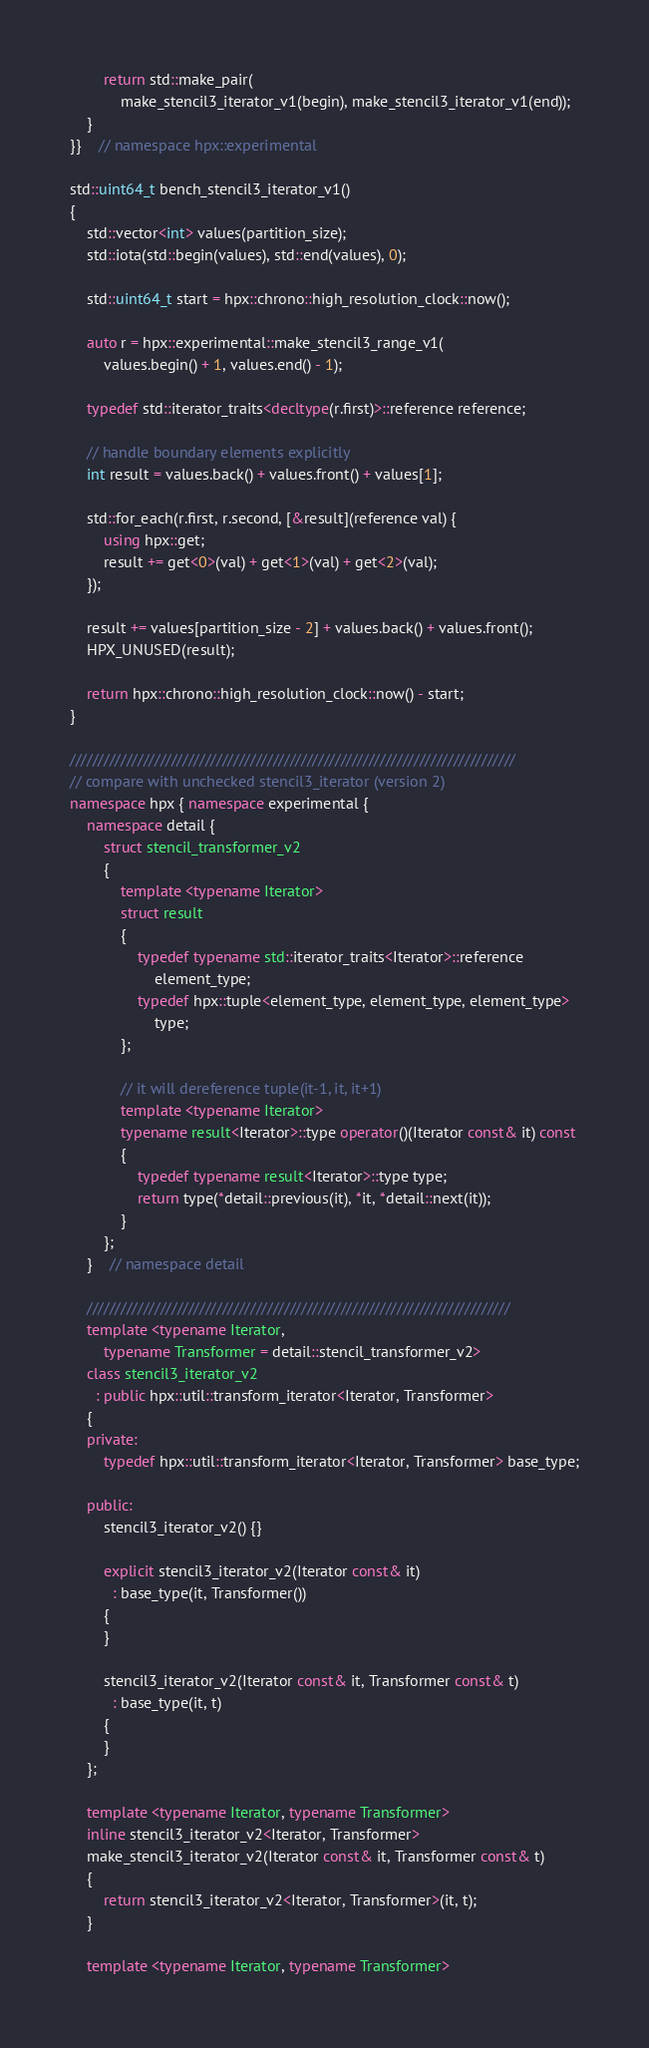Convert code to text. <code><loc_0><loc_0><loc_500><loc_500><_C++_>        return std::make_pair(
            make_stencil3_iterator_v1(begin), make_stencil3_iterator_v1(end));
    }
}}    // namespace hpx::experimental

std::uint64_t bench_stencil3_iterator_v1()
{
    std::vector<int> values(partition_size);
    std::iota(std::begin(values), std::end(values), 0);

    std::uint64_t start = hpx::chrono::high_resolution_clock::now();

    auto r = hpx::experimental::make_stencil3_range_v1(
        values.begin() + 1, values.end() - 1);

    typedef std::iterator_traits<decltype(r.first)>::reference reference;

    // handle boundary elements explicitly
    int result = values.back() + values.front() + values[1];

    std::for_each(r.first, r.second, [&result](reference val) {
        using hpx::get;
        result += get<0>(val) + get<1>(val) + get<2>(val);
    });

    result += values[partition_size - 2] + values.back() + values.front();
    HPX_UNUSED(result);

    return hpx::chrono::high_resolution_clock::now() - start;
}

///////////////////////////////////////////////////////////////////////////////
// compare with unchecked stencil3_iterator (version 2)
namespace hpx { namespace experimental {
    namespace detail {
        struct stencil_transformer_v2
        {
            template <typename Iterator>
            struct result
            {
                typedef typename std::iterator_traits<Iterator>::reference
                    element_type;
                typedef hpx::tuple<element_type, element_type, element_type>
                    type;
            };

            // it will dereference tuple(it-1, it, it+1)
            template <typename Iterator>
            typename result<Iterator>::type operator()(Iterator const& it) const
            {
                typedef typename result<Iterator>::type type;
                return type(*detail::previous(it), *it, *detail::next(it));
            }
        };
    }    // namespace detail

    ///////////////////////////////////////////////////////////////////////////
    template <typename Iterator,
        typename Transformer = detail::stencil_transformer_v2>
    class stencil3_iterator_v2
      : public hpx::util::transform_iterator<Iterator, Transformer>
    {
    private:
        typedef hpx::util::transform_iterator<Iterator, Transformer> base_type;

    public:
        stencil3_iterator_v2() {}

        explicit stencil3_iterator_v2(Iterator const& it)
          : base_type(it, Transformer())
        {
        }

        stencil3_iterator_v2(Iterator const& it, Transformer const& t)
          : base_type(it, t)
        {
        }
    };

    template <typename Iterator, typename Transformer>
    inline stencil3_iterator_v2<Iterator, Transformer>
    make_stencil3_iterator_v2(Iterator const& it, Transformer const& t)
    {
        return stencil3_iterator_v2<Iterator, Transformer>(it, t);
    }

    template <typename Iterator, typename Transformer></code> 